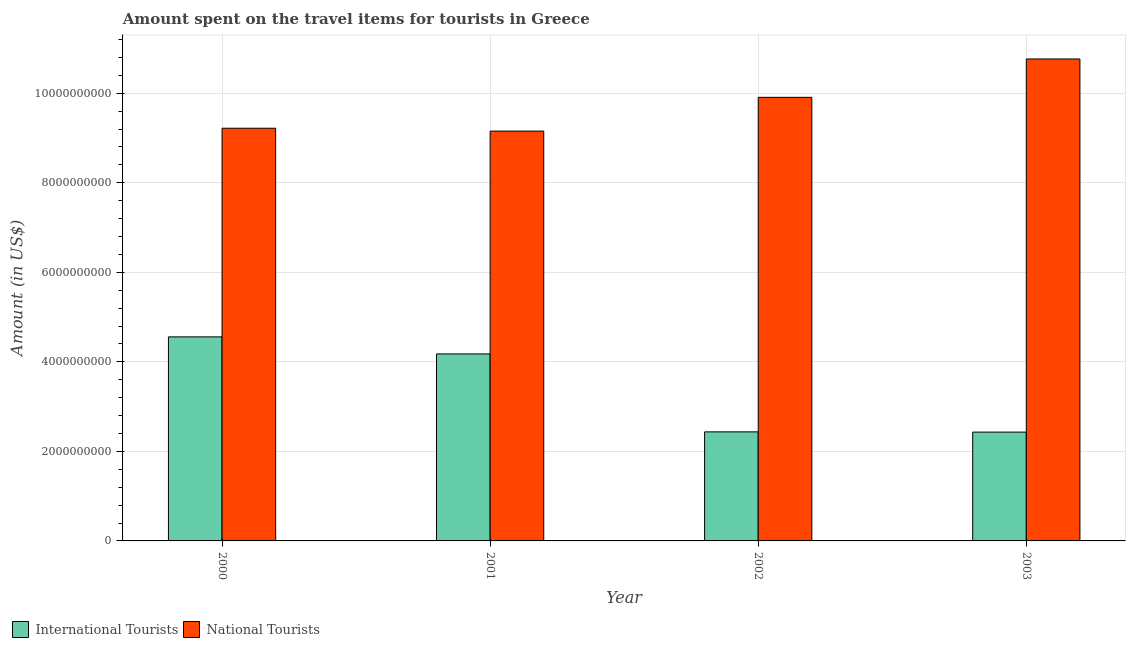How many different coloured bars are there?
Provide a short and direct response. 2. How many groups of bars are there?
Offer a terse response. 4. Are the number of bars per tick equal to the number of legend labels?
Provide a succinct answer. Yes. How many bars are there on the 1st tick from the left?
Provide a short and direct response. 2. How many bars are there on the 2nd tick from the right?
Your response must be concise. 2. What is the amount spent on travel items of national tourists in 2001?
Provide a short and direct response. 9.16e+09. Across all years, what is the maximum amount spent on travel items of international tourists?
Offer a terse response. 4.56e+09. Across all years, what is the minimum amount spent on travel items of international tourists?
Keep it short and to the point. 2.43e+09. In which year was the amount spent on travel items of national tourists maximum?
Offer a terse response. 2003. What is the total amount spent on travel items of national tourists in the graph?
Give a very brief answer. 3.90e+1. What is the difference between the amount spent on travel items of international tourists in 2000 and that in 2002?
Give a very brief answer. 2.12e+09. What is the difference between the amount spent on travel items of international tourists in 2003 and the amount spent on travel items of national tourists in 2001?
Your answer should be very brief. -1.75e+09. What is the average amount spent on travel items of national tourists per year?
Give a very brief answer. 9.76e+09. What is the ratio of the amount spent on travel items of international tourists in 2001 to that in 2002?
Keep it short and to the point. 1.71. Is the difference between the amount spent on travel items of national tourists in 2001 and 2002 greater than the difference between the amount spent on travel items of international tourists in 2001 and 2002?
Keep it short and to the point. No. What is the difference between the highest and the second highest amount spent on travel items of international tourists?
Give a very brief answer. 3.81e+08. What is the difference between the highest and the lowest amount spent on travel items of national tourists?
Offer a terse response. 1.61e+09. What does the 2nd bar from the left in 2000 represents?
Your answer should be very brief. National Tourists. What does the 2nd bar from the right in 2003 represents?
Your answer should be compact. International Tourists. What is the difference between two consecutive major ticks on the Y-axis?
Provide a succinct answer. 2.00e+09. Are the values on the major ticks of Y-axis written in scientific E-notation?
Give a very brief answer. No. Does the graph contain any zero values?
Provide a short and direct response. No. Where does the legend appear in the graph?
Keep it short and to the point. Bottom left. How many legend labels are there?
Make the answer very short. 2. How are the legend labels stacked?
Your response must be concise. Horizontal. What is the title of the graph?
Your response must be concise. Amount spent on the travel items for tourists in Greece. Does "Rural Population" appear as one of the legend labels in the graph?
Your response must be concise. No. What is the Amount (in US$) of International Tourists in 2000?
Keep it short and to the point. 4.56e+09. What is the Amount (in US$) of National Tourists in 2000?
Ensure brevity in your answer.  9.22e+09. What is the Amount (in US$) of International Tourists in 2001?
Your answer should be compact. 4.18e+09. What is the Amount (in US$) in National Tourists in 2001?
Give a very brief answer. 9.16e+09. What is the Amount (in US$) of International Tourists in 2002?
Provide a succinct answer. 2.44e+09. What is the Amount (in US$) of National Tourists in 2002?
Offer a very short reply. 9.91e+09. What is the Amount (in US$) of International Tourists in 2003?
Give a very brief answer. 2.43e+09. What is the Amount (in US$) of National Tourists in 2003?
Provide a short and direct response. 1.08e+1. Across all years, what is the maximum Amount (in US$) in International Tourists?
Your answer should be very brief. 4.56e+09. Across all years, what is the maximum Amount (in US$) of National Tourists?
Keep it short and to the point. 1.08e+1. Across all years, what is the minimum Amount (in US$) of International Tourists?
Make the answer very short. 2.43e+09. Across all years, what is the minimum Amount (in US$) in National Tourists?
Make the answer very short. 9.16e+09. What is the total Amount (in US$) of International Tourists in the graph?
Provide a succinct answer. 1.36e+1. What is the total Amount (in US$) of National Tourists in the graph?
Offer a very short reply. 3.90e+1. What is the difference between the Amount (in US$) in International Tourists in 2000 and that in 2001?
Offer a terse response. 3.81e+08. What is the difference between the Amount (in US$) of National Tourists in 2000 and that in 2001?
Make the answer very short. 6.40e+07. What is the difference between the Amount (in US$) of International Tourists in 2000 and that in 2002?
Offer a very short reply. 2.12e+09. What is the difference between the Amount (in US$) of National Tourists in 2000 and that in 2002?
Provide a short and direct response. -6.90e+08. What is the difference between the Amount (in US$) in International Tourists in 2000 and that in 2003?
Offer a very short reply. 2.13e+09. What is the difference between the Amount (in US$) of National Tourists in 2000 and that in 2003?
Your answer should be compact. -1.55e+09. What is the difference between the Amount (in US$) of International Tourists in 2001 and that in 2002?
Provide a short and direct response. 1.74e+09. What is the difference between the Amount (in US$) of National Tourists in 2001 and that in 2002?
Your answer should be very brief. -7.54e+08. What is the difference between the Amount (in US$) in International Tourists in 2001 and that in 2003?
Offer a very short reply. 1.75e+09. What is the difference between the Amount (in US$) in National Tourists in 2001 and that in 2003?
Your response must be concise. -1.61e+09. What is the difference between the Amount (in US$) of International Tourists in 2002 and that in 2003?
Your answer should be very brief. 5.00e+06. What is the difference between the Amount (in US$) in National Tourists in 2002 and that in 2003?
Ensure brevity in your answer.  -8.57e+08. What is the difference between the Amount (in US$) of International Tourists in 2000 and the Amount (in US$) of National Tourists in 2001?
Your answer should be very brief. -4.60e+09. What is the difference between the Amount (in US$) in International Tourists in 2000 and the Amount (in US$) in National Tourists in 2002?
Your response must be concise. -5.35e+09. What is the difference between the Amount (in US$) in International Tourists in 2000 and the Amount (in US$) in National Tourists in 2003?
Make the answer very short. -6.21e+09. What is the difference between the Amount (in US$) in International Tourists in 2001 and the Amount (in US$) in National Tourists in 2002?
Provide a short and direct response. -5.73e+09. What is the difference between the Amount (in US$) of International Tourists in 2001 and the Amount (in US$) of National Tourists in 2003?
Your answer should be compact. -6.59e+09. What is the difference between the Amount (in US$) in International Tourists in 2002 and the Amount (in US$) in National Tourists in 2003?
Offer a terse response. -8.33e+09. What is the average Amount (in US$) in International Tourists per year?
Provide a succinct answer. 3.40e+09. What is the average Amount (in US$) of National Tourists per year?
Provide a short and direct response. 9.76e+09. In the year 2000, what is the difference between the Amount (in US$) of International Tourists and Amount (in US$) of National Tourists?
Provide a succinct answer. -4.66e+09. In the year 2001, what is the difference between the Amount (in US$) of International Tourists and Amount (in US$) of National Tourists?
Your answer should be compact. -4.98e+09. In the year 2002, what is the difference between the Amount (in US$) in International Tourists and Amount (in US$) in National Tourists?
Your answer should be very brief. -7.47e+09. In the year 2003, what is the difference between the Amount (in US$) in International Tourists and Amount (in US$) in National Tourists?
Your response must be concise. -8.34e+09. What is the ratio of the Amount (in US$) of International Tourists in 2000 to that in 2001?
Your response must be concise. 1.09. What is the ratio of the Amount (in US$) in International Tourists in 2000 to that in 2002?
Give a very brief answer. 1.87. What is the ratio of the Amount (in US$) in National Tourists in 2000 to that in 2002?
Give a very brief answer. 0.93. What is the ratio of the Amount (in US$) in International Tourists in 2000 to that in 2003?
Your response must be concise. 1.87. What is the ratio of the Amount (in US$) in National Tourists in 2000 to that in 2003?
Provide a short and direct response. 0.86. What is the ratio of the Amount (in US$) of International Tourists in 2001 to that in 2002?
Ensure brevity in your answer.  1.71. What is the ratio of the Amount (in US$) in National Tourists in 2001 to that in 2002?
Give a very brief answer. 0.92. What is the ratio of the Amount (in US$) of International Tourists in 2001 to that in 2003?
Your response must be concise. 1.72. What is the ratio of the Amount (in US$) in National Tourists in 2001 to that in 2003?
Give a very brief answer. 0.85. What is the ratio of the Amount (in US$) of International Tourists in 2002 to that in 2003?
Your answer should be very brief. 1. What is the ratio of the Amount (in US$) in National Tourists in 2002 to that in 2003?
Offer a very short reply. 0.92. What is the difference between the highest and the second highest Amount (in US$) of International Tourists?
Offer a very short reply. 3.81e+08. What is the difference between the highest and the second highest Amount (in US$) in National Tourists?
Offer a very short reply. 8.57e+08. What is the difference between the highest and the lowest Amount (in US$) of International Tourists?
Offer a terse response. 2.13e+09. What is the difference between the highest and the lowest Amount (in US$) in National Tourists?
Provide a short and direct response. 1.61e+09. 